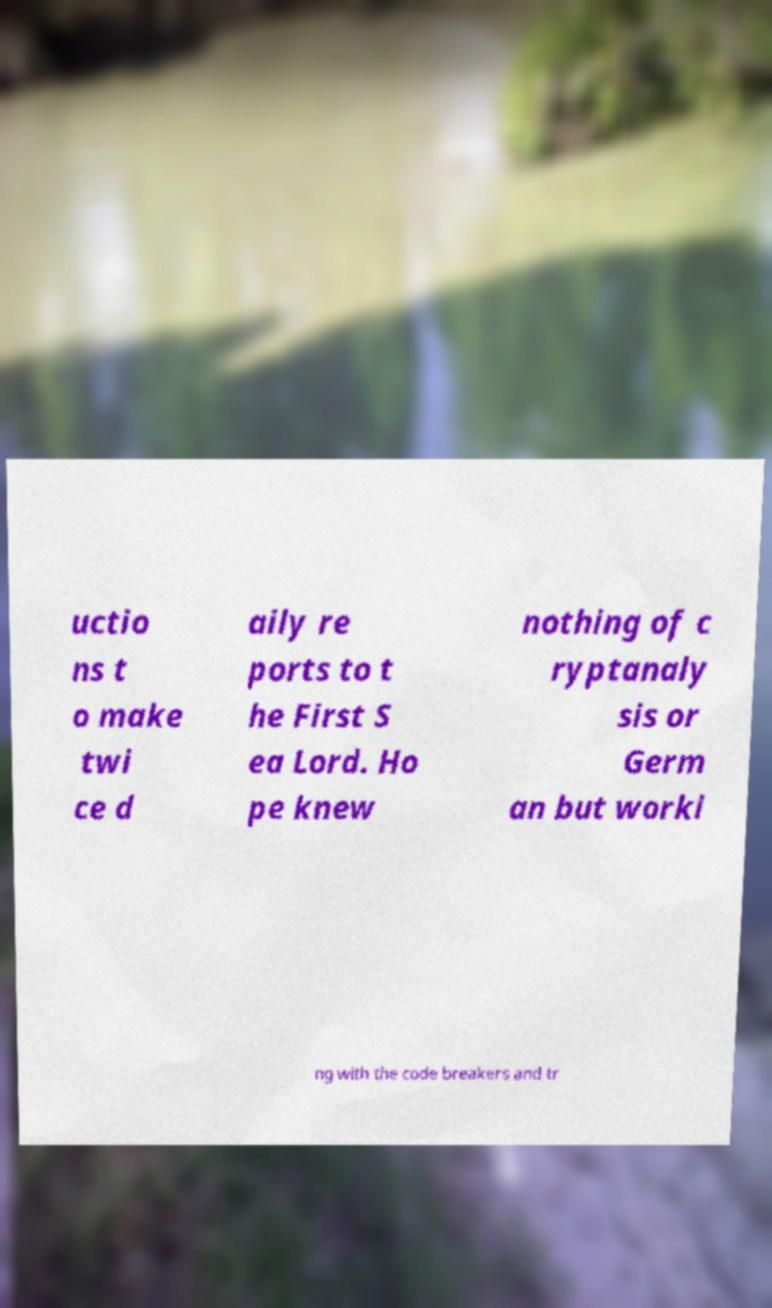Can you read and provide the text displayed in the image?This photo seems to have some interesting text. Can you extract and type it out for me? uctio ns t o make twi ce d aily re ports to t he First S ea Lord. Ho pe knew nothing of c ryptanaly sis or Germ an but worki ng with the code breakers and tr 